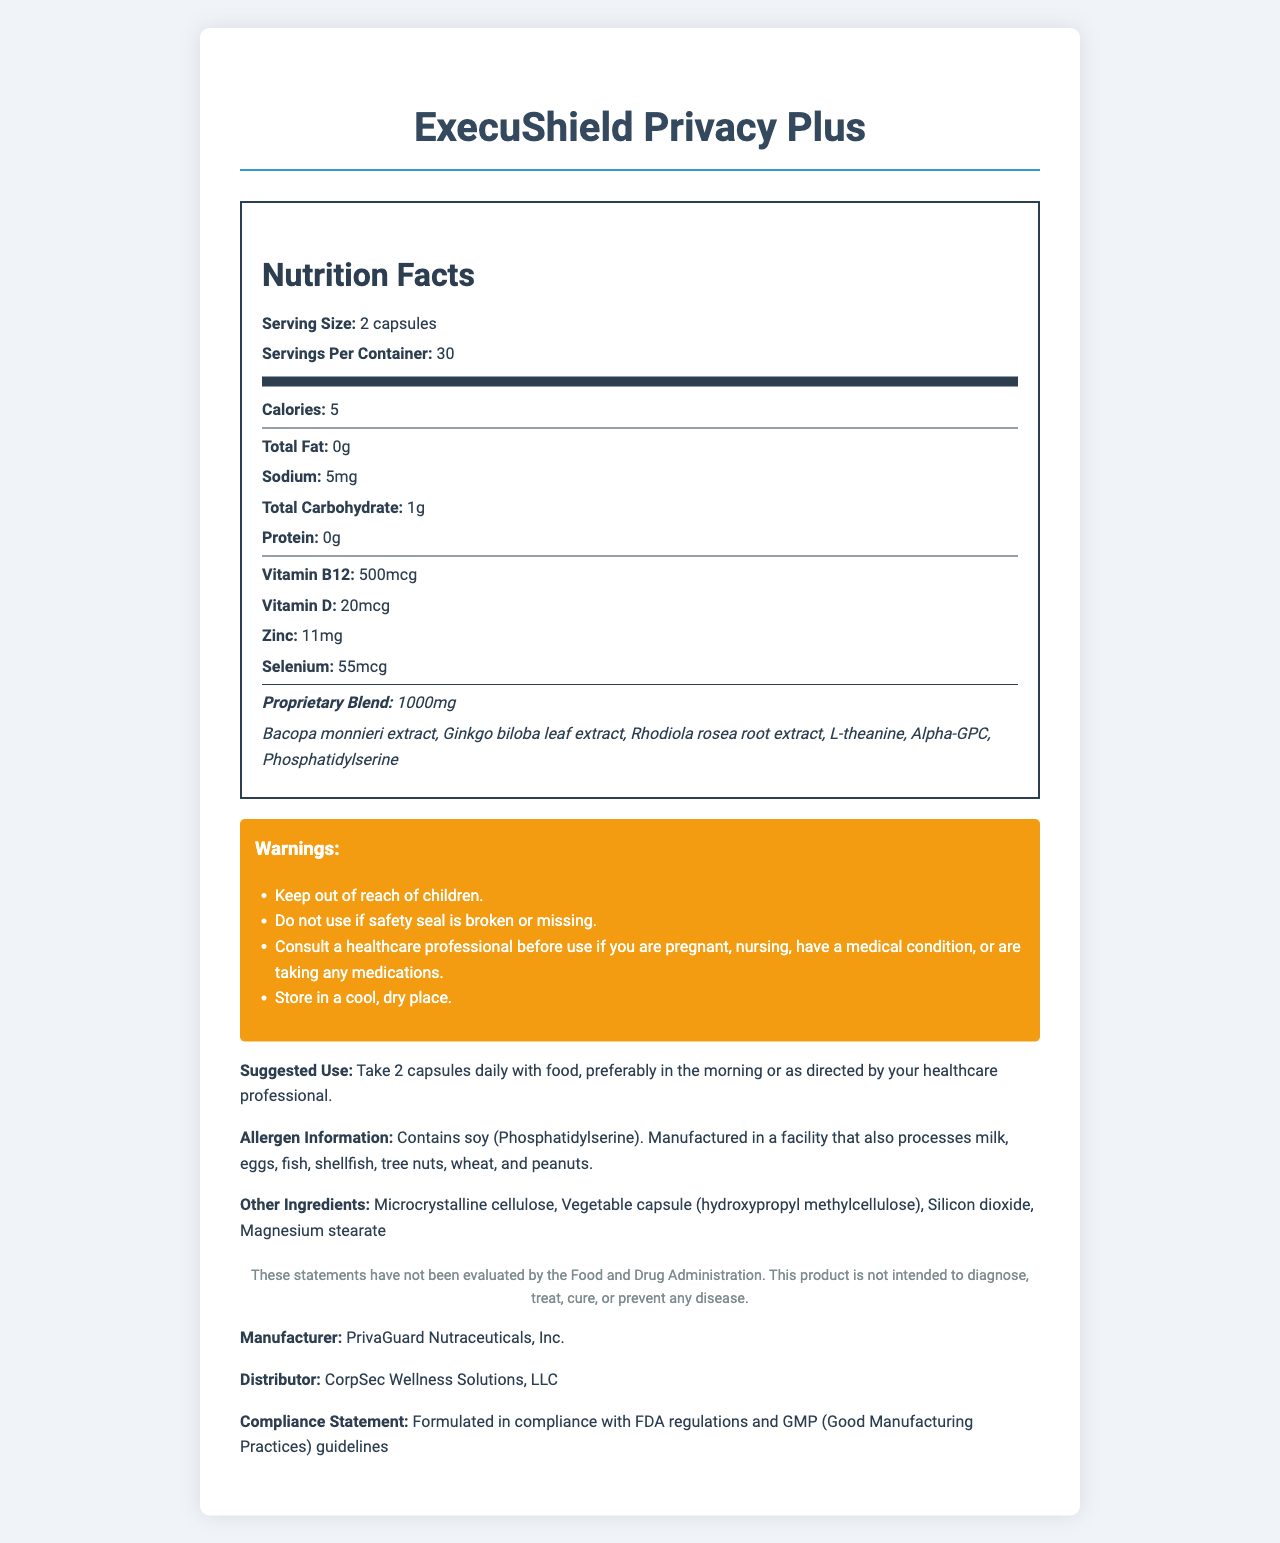what is the serving size? The document states that the serving size is "2 capsules."
Answer: 2 capsules how many servings are there in one container? The document mentions that there are "30 servings per container."
Answer: 30 how many calories are in one serving? The document lists the calorie count as "5."
Answer: 5 which vitamin has the highest amount per serving, Vitamin B12 or Vitamin D? Vitamin B12 has 500mcg per serving, whereas Vitamin D has 20mcg per serving.
Answer: Vitamin B12 name three ingredients in the proprietary blend The proprietary blend includes Bacopa monnieri extract, Ginkgo biloba leaf extract, Rhodiola rosea root extract along with three other ingredients.
Answer: Bacopa monnieri extract, Ginkgo biloba leaf extract, Rhodiola rosea root extract what is the sodium content per serving? The document states that the sodium content per serving is "5mg."
Answer: 5mg what is the suggested use for this product? The document advises users to take 2 capsules daily with food, preferably in the morning, or as directed by a healthcare professional.
Answer: Take 2 capsules daily with food, preferably in the morning or as directed by your healthcare professional. does the product contain any allergens? The document mentions that the product "Contains soy (Phosphatidylserine)" and is "Manufactured in a facility that also processes milk, eggs, fish, shellfish, tree nuts, wheat, and peanuts."
Answer: Yes what is the product designed for? A. Enhancing physical strength B. Supporting cognitive function and mental clarity C. Improving cardiovascular health The document lists "Supports cognitive function and mental clarity" as one of the product features.
Answer: B who is the manufacturer of this product? A. PrivaGuard Nutraceuticals, Inc. B. CorpSec Wellness Solutions, LLC C. DailyHealth Supplements Co. The document states that the manufacturer is "PrivaGuard Nutraceuticals, Inc."
Answer: A is this product intended to treat any diseases? The document includes a legal disclaimer stating, "This product is not intended to diagnose, treat, cure, or prevent any disease."
Answer: No does this document comply with FDA regulations? The document includes a compliance statement: "Formulated in compliance with FDA regulations and GMP (Good Manufacturing Practices) guidelines."
Answer: Yes summarize the main features and target audience of ExecuShield Privacy Plus in one or two sentences. The summary covers the main features and the target audience, detailing its benefits for cognitive functions and its compliance status.
Answer: ExecuShield Privacy Plus is designed to support cognitive function, mental clarity, focus, attention to detail, stress resilience, and emotional balance for corporate executives, legal professionals, and individuals in high-stakes positions. It is manufactured by PrivaGuard Nutraceuticals, Inc. and complies with FDA regulations and GMP guidelines. what specific benefits does the product claim to offer? The document lists these four specific benefits as the product features.
Answer: Supports cognitive function and mental clarity, Enhances focus and attention to detail, Promotes stress resilience and emotional balance, Aids in maintaining discretion and confidentiality awareness what is the amount of zinc per serving? The document indicates that each serving contains "11mg" of zinc.
Answer: 11mg how should this product be stored? One of the warnings in the document advises to "Store in a cool, dry place."
Answer: Store in a cool, dry place. what is the proprietary blend amount per serving? The document mentions a "Proprietary Blend: 1000mg."
Answer: 1000mg can someone who is pregnant take this product without consulting a healthcare professional? The document warns, "Consult a healthcare professional before use if you are pregnant."
Answer: No what is the legal disclaimer provided in the document? The document contains this specific legal disclaimer.
Answer: These statements have not been evaluated by the Food and Drug Administration. This product is not intended to diagnose, treat, cure, or prevent any disease. name a non-active ingredient in the product. The document lists "Microcrystalline cellulose" as one of the other ingredients.
Answer: Microcrystalline cellulose where was this product manufactured? The document does not mention the location where the product was manufactured.
Answer: Not enough information 